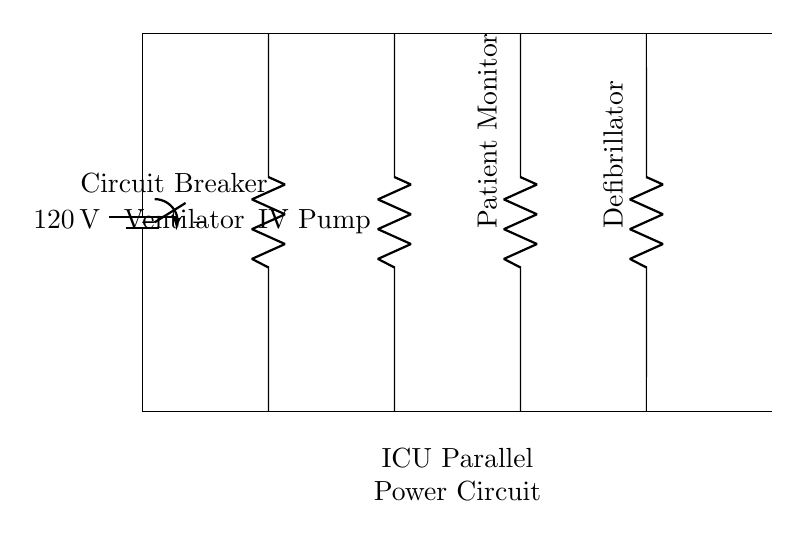What is the voltage of this circuit? The voltage in the circuit is represented by the battery symbol, which shows a potential difference of 120 volts between the two power lines.
Answer: 120 volts What types of medical equipment are connected in this circuit? The circuit diagram includes four pieces of medical equipment: a ventilator, an IV pump, a patient monitor, and a defibrillator, indicated by their respective labels along the branches.
Answer: Ventilator, IV pump, patient monitor, defibrillator How many branches are there in this parallel circuit? The circuit clearly shows four separate branches, each connected to the main power lines at the top and bottom, corresponding to different medical devices.
Answer: Four branches What happens if one device fails in this parallel circuit? In a parallel circuit, if one device (branch) fails, the other devices continue to operate normally because each device has an independent connection to the power supply.
Answer: Other devices remain operational What component is used to ensure safety in this circuit? The circuit includes a circuit breaker symbol, which indicates a protective device designed to disconnect the circuit in case of an overload or fault condition, ensuring safety for connected equipment.
Answer: Circuit breaker What is the role of the circuit breaker in this setup? The circuit breaker acts as a safety measure by interrupting the power supply in the event of a fault, preventing damage to the medical equipment and hazards to patients or staff.
Answer: Safety measure What is the significance of having a parallel configuration for these devices? A parallel configuration allows each medical device to receive the same voltage from the power supply while operating independently. This ensures reliability and reduces the impact of a single device failure on the overall operation.
Answer: Reliability and independent operation 